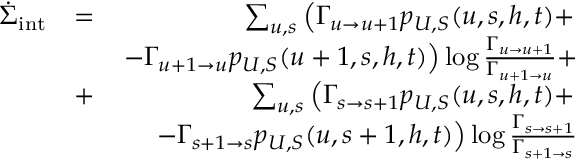Convert formula to latex. <formula><loc_0><loc_0><loc_500><loc_500>\begin{array} { r l r } { \dot { \Sigma } _ { i n t } } & { = } & { \sum _ { u , s } \left ( \Gamma _ { u \to u + 1 } p _ { U , S } ( u , s , h , t ) + } \\ & { - \Gamma _ { u + 1 \to u } p _ { U , S } ( u + 1 , s , h , t ) \right ) \log \frac { \Gamma _ { u \to u + 1 } } { \Gamma _ { u + 1 \to u } } + } \\ & { + } & { \sum _ { u , s } \left ( \Gamma _ { s \to s + 1 } p _ { U , S } ( u , s , h , t ) + } \\ & { - \Gamma _ { s + 1 \to s } p _ { U , S } ( u , s + 1 , h , t ) \right ) \log \frac { \Gamma _ { s \to s + 1 } } { \Gamma _ { s + 1 \to s } } } \end{array}</formula> 